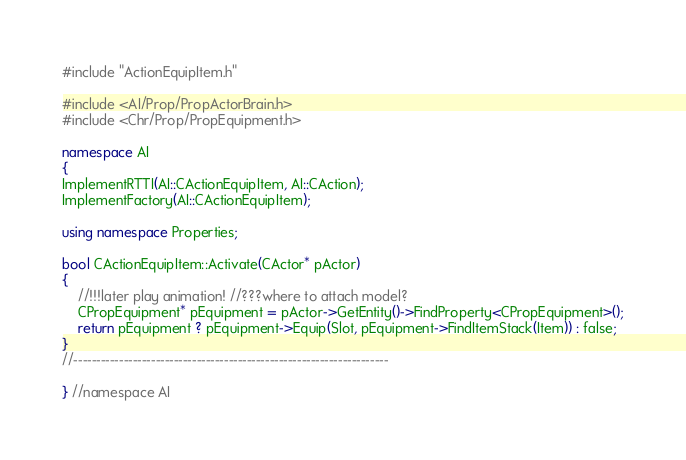Convert code to text. <code><loc_0><loc_0><loc_500><loc_500><_C++_>#include "ActionEquipItem.h"

#include <AI/Prop/PropActorBrain.h>
#include <Chr/Prop/PropEquipment.h>

namespace AI
{
ImplementRTTI(AI::CActionEquipItem, AI::CAction);
ImplementFactory(AI::CActionEquipItem);

using namespace Properties;

bool CActionEquipItem::Activate(CActor* pActor)
{
	//!!!later play animation! //???where to attach model?
	CPropEquipment* pEquipment = pActor->GetEntity()->FindProperty<CPropEquipment>();
	return pEquipment ? pEquipment->Equip(Slot, pEquipment->FindItemStack(Item)) : false;
}
//---------------------------------------------------------------------

} //namespace AI</code> 